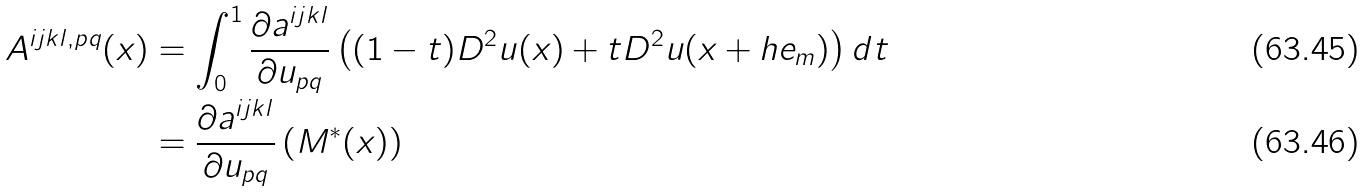<formula> <loc_0><loc_0><loc_500><loc_500>A ^ { i j k l , p q } ( x ) & = \int _ { 0 } ^ { 1 } \frac { \partial a ^ { i j k l } } { \partial u _ { p q } } \left ( ( 1 - t ) D ^ { 2 } u ( x ) + t D ^ { 2 } u ( x + h e _ { m } ) \right ) d t \\ & = \frac { \partial a ^ { i j k l } } { \partial u _ { p q } } \left ( M ^ { \ast } ( x ) \right )</formula> 